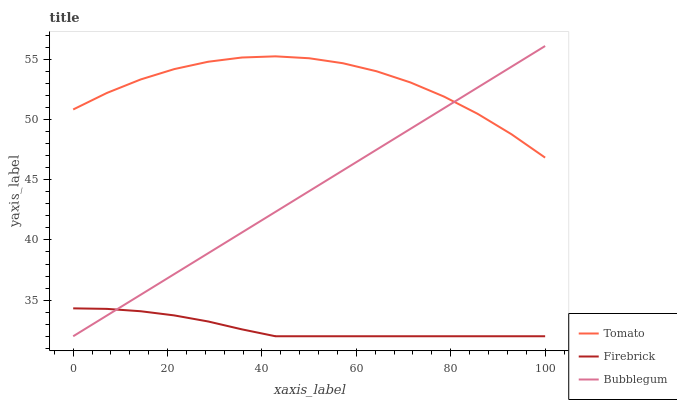Does Firebrick have the minimum area under the curve?
Answer yes or no. Yes. Does Tomato have the maximum area under the curve?
Answer yes or no. Yes. Does Bubblegum have the minimum area under the curve?
Answer yes or no. No. Does Bubblegum have the maximum area under the curve?
Answer yes or no. No. Is Bubblegum the smoothest?
Answer yes or no. Yes. Is Tomato the roughest?
Answer yes or no. Yes. Is Firebrick the smoothest?
Answer yes or no. No. Is Firebrick the roughest?
Answer yes or no. No. Does Firebrick have the lowest value?
Answer yes or no. Yes. Does Bubblegum have the highest value?
Answer yes or no. Yes. Does Firebrick have the highest value?
Answer yes or no. No. Is Firebrick less than Tomato?
Answer yes or no. Yes. Is Tomato greater than Firebrick?
Answer yes or no. Yes. Does Firebrick intersect Bubblegum?
Answer yes or no. Yes. Is Firebrick less than Bubblegum?
Answer yes or no. No. Is Firebrick greater than Bubblegum?
Answer yes or no. No. Does Firebrick intersect Tomato?
Answer yes or no. No. 